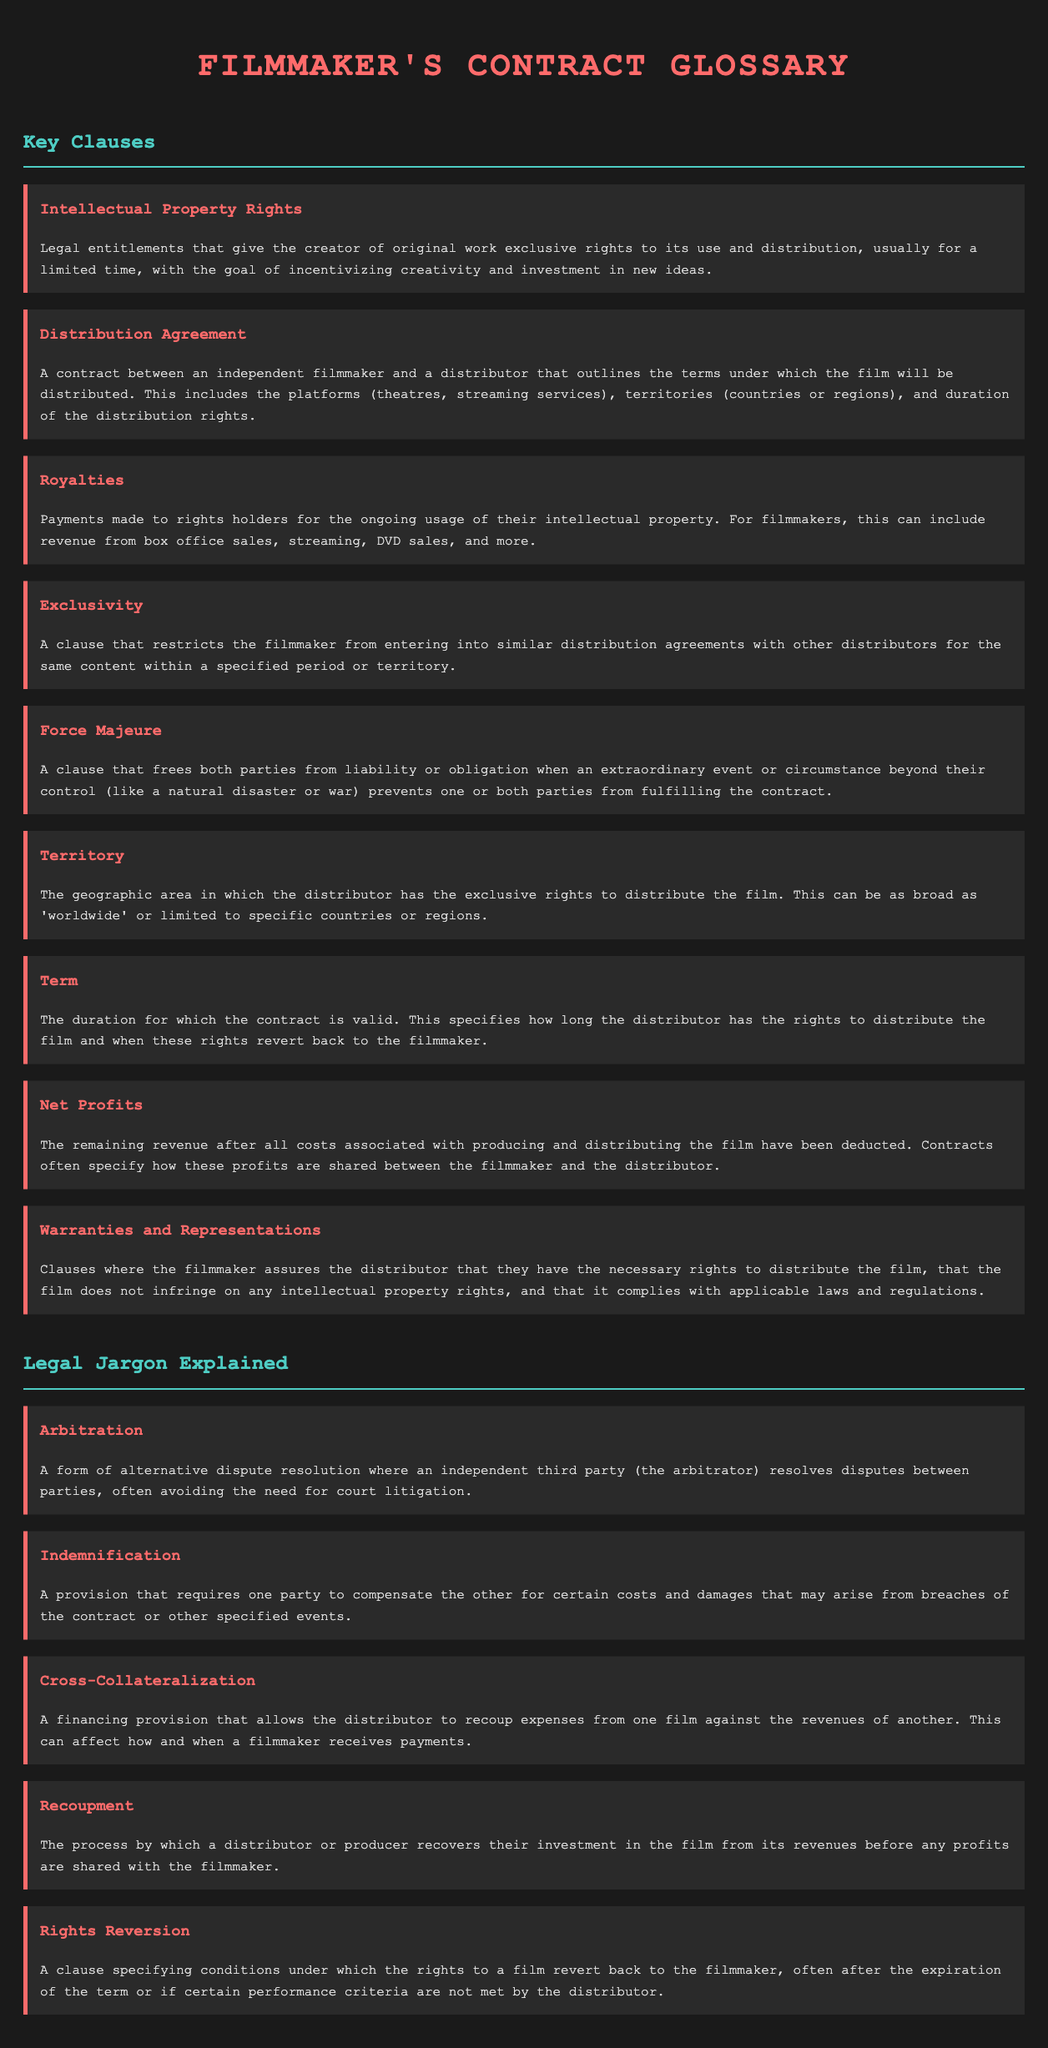what are Intellectual Property Rights? Intellectual Property Rights are legal entitlements that give the creator of original work exclusive rights to its use and distribution.
Answer: exclusive rights what is a Distribution Agreement? A Distribution Agreement is a contract that outlines the terms under which the film will be distributed, including platforms, territories, and duration.
Answer: contract between filmmaker and distributor what does Net Profits refer to? Net Profits refers to the remaining revenue after all costs associated with producing and distributing the film have been deducted.
Answer: remaining revenue what does Exclusivity restrict? Exclusivity restricts the filmmaker from entering into similar distribution agreements with other distributors for the same content.
Answer: similar distribution agreements what is the purpose of Warranties and Representations? The purpose is to assure the distributor that the filmmaker has the necessary rights to distribute the film and that it complies with applicable laws.
Answer: assurance to distributor when can rights revert back to the filmmaker? Rights can revert back after the expiration of the term or if certain performance criteria are not met by the distributor.
Answer: after expiration or unmet criteria what is the meaning of Recoupment? Recoupment is the process by which a distributor or producer recovers their investment in the film from its revenues before sharing profits.
Answer: recovering investment what does a Force Majeure clause address? A Force Majeure clause addresses circumstances beyond control that prevent fulfilling contractual obligations.
Answer: extraordinary events what does Indemnification require? Indemnification requires one party to compensate the other for certain costs and damages arising from breaches of the contract.
Answer: compensation for costs 